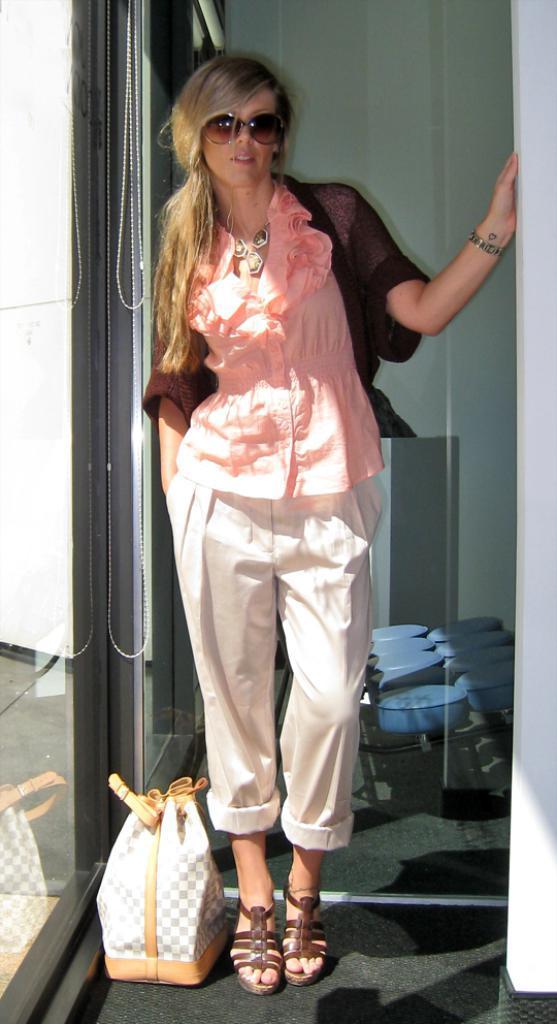Please provide a concise description of this image. A lady with pink shirt and maroon jacket is standing. She is wearing goggles beside her there is a bag. To the left side there is a door with glass. And to the right side there are blue color items. 